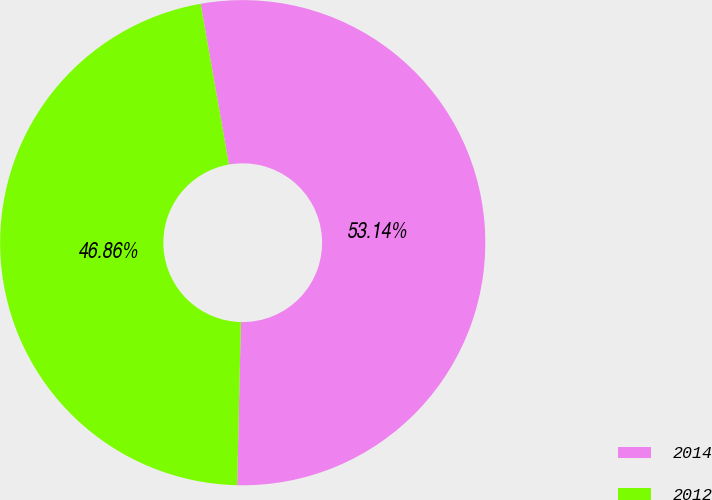<chart> <loc_0><loc_0><loc_500><loc_500><pie_chart><fcel>2014<fcel>2012<nl><fcel>53.14%<fcel>46.86%<nl></chart> 